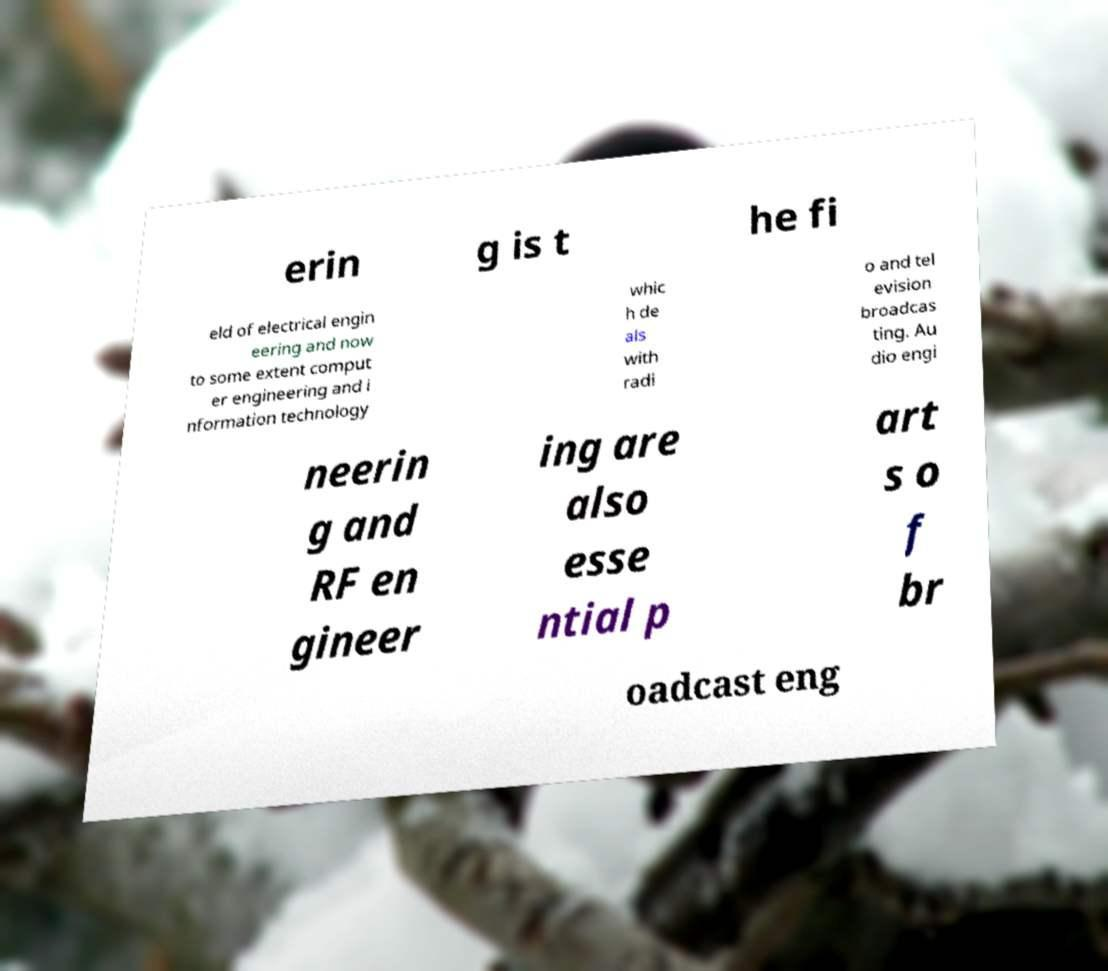Could you extract and type out the text from this image? erin g is t he fi eld of electrical engin eering and now to some extent comput er engineering and i nformation technology whic h de als with radi o and tel evision broadcas ting. Au dio engi neerin g and RF en gineer ing are also esse ntial p art s o f br oadcast eng 